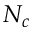<formula> <loc_0><loc_0><loc_500><loc_500>N _ { c }</formula> 